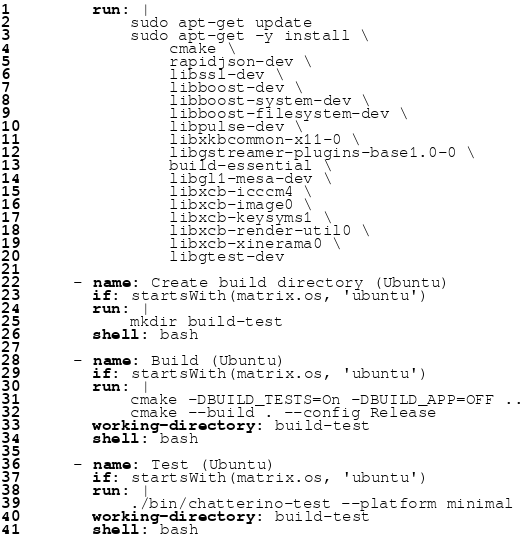Convert code to text. <code><loc_0><loc_0><loc_500><loc_500><_YAML_>        run: |
            sudo apt-get update
            sudo apt-get -y install \
                cmake \
                rapidjson-dev \
                libssl-dev \
                libboost-dev \
                libboost-system-dev \
                libboost-filesystem-dev \
                libpulse-dev \
                libxkbcommon-x11-0 \
                libgstreamer-plugins-base1.0-0 \
                build-essential \
                libgl1-mesa-dev \
                libxcb-icccm4 \
                libxcb-image0 \
                libxcb-keysyms1 \
                libxcb-render-util0 \
                libxcb-xinerama0 \
                libgtest-dev

      - name: Create build directory (Ubuntu)
        if: startsWith(matrix.os, 'ubuntu')
        run: |
            mkdir build-test
        shell: bash

      - name: Build (Ubuntu)
        if: startsWith(matrix.os, 'ubuntu')
        run: |
            cmake -DBUILD_TESTS=On -DBUILD_APP=OFF ..
            cmake --build . --config Release
        working-directory: build-test
        shell: bash

      - name: Test (Ubuntu)
        if: startsWith(matrix.os, 'ubuntu')
        run: |
            ./bin/chatterino-test --platform minimal
        working-directory: build-test
        shell: bash
</code> 